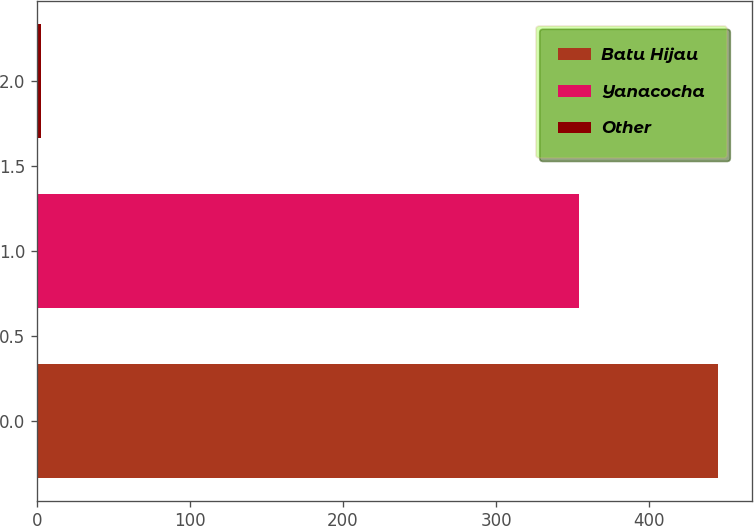<chart> <loc_0><loc_0><loc_500><loc_500><bar_chart><fcel>Batu Hijau<fcel>Yanacocha<fcel>Other<nl><fcel>445<fcel>354<fcel>3<nl></chart> 